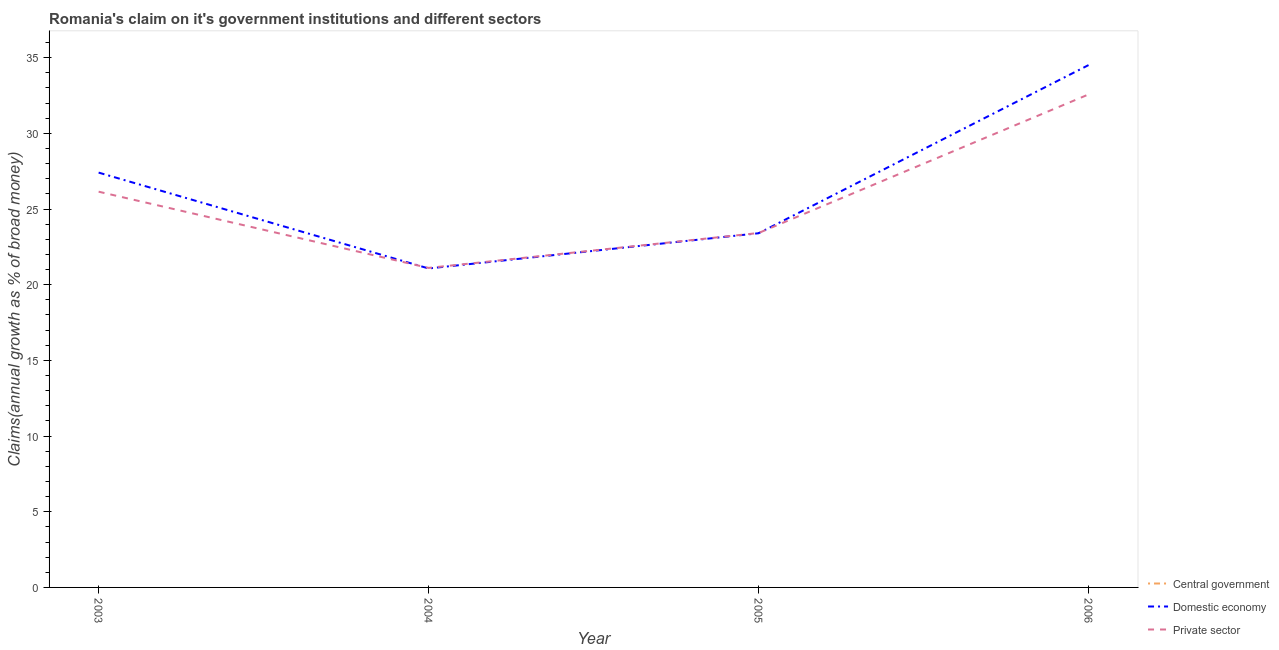Is the number of lines equal to the number of legend labels?
Offer a very short reply. No. What is the percentage of claim on the domestic economy in 2003?
Your answer should be compact. 27.41. Across all years, what is the maximum percentage of claim on the domestic economy?
Your answer should be compact. 34.51. In which year was the percentage of claim on the private sector maximum?
Your answer should be compact. 2006. What is the total percentage of claim on the domestic economy in the graph?
Offer a terse response. 106.39. What is the difference between the percentage of claim on the private sector in 2004 and that in 2005?
Provide a succinct answer. -2.31. What is the difference between the percentage of claim on the domestic economy in 2006 and the percentage of claim on the private sector in 2004?
Your answer should be compact. 13.4. In the year 2006, what is the difference between the percentage of claim on the domestic economy and percentage of claim on the private sector?
Your response must be concise. 1.94. What is the ratio of the percentage of claim on the domestic economy in 2003 to that in 2006?
Offer a terse response. 0.79. What is the difference between the highest and the second highest percentage of claim on the private sector?
Make the answer very short. 6.43. What is the difference between the highest and the lowest percentage of claim on the private sector?
Your response must be concise. 11.46. In how many years, is the percentage of claim on the private sector greater than the average percentage of claim on the private sector taken over all years?
Make the answer very short. 2. Does the percentage of claim on the central government monotonically increase over the years?
Your response must be concise. No. Is the percentage of claim on the domestic economy strictly less than the percentage of claim on the private sector over the years?
Your answer should be very brief. No. How many lines are there?
Your answer should be compact. 2. How many years are there in the graph?
Offer a very short reply. 4. What is the difference between two consecutive major ticks on the Y-axis?
Provide a succinct answer. 5. Does the graph contain grids?
Your answer should be very brief. No. Where does the legend appear in the graph?
Provide a succinct answer. Bottom right. How many legend labels are there?
Provide a succinct answer. 3. What is the title of the graph?
Keep it short and to the point. Romania's claim on it's government institutions and different sectors. Does "Social Protection and Labor" appear as one of the legend labels in the graph?
Ensure brevity in your answer.  No. What is the label or title of the X-axis?
Give a very brief answer. Year. What is the label or title of the Y-axis?
Provide a succinct answer. Claims(annual growth as % of broad money). What is the Claims(annual growth as % of broad money) of Domestic economy in 2003?
Make the answer very short. 27.41. What is the Claims(annual growth as % of broad money) in Private sector in 2003?
Your response must be concise. 26.15. What is the Claims(annual growth as % of broad money) in Central government in 2004?
Provide a succinct answer. 0. What is the Claims(annual growth as % of broad money) of Domestic economy in 2004?
Offer a terse response. 21.07. What is the Claims(annual growth as % of broad money) of Private sector in 2004?
Make the answer very short. 21.11. What is the Claims(annual growth as % of broad money) in Domestic economy in 2005?
Offer a very short reply. 23.4. What is the Claims(annual growth as % of broad money) of Private sector in 2005?
Ensure brevity in your answer.  23.42. What is the Claims(annual growth as % of broad money) of Central government in 2006?
Offer a very short reply. 0. What is the Claims(annual growth as % of broad money) in Domestic economy in 2006?
Keep it short and to the point. 34.51. What is the Claims(annual growth as % of broad money) in Private sector in 2006?
Make the answer very short. 32.57. Across all years, what is the maximum Claims(annual growth as % of broad money) of Domestic economy?
Ensure brevity in your answer.  34.51. Across all years, what is the maximum Claims(annual growth as % of broad money) of Private sector?
Your answer should be compact. 32.57. Across all years, what is the minimum Claims(annual growth as % of broad money) of Domestic economy?
Your answer should be compact. 21.07. Across all years, what is the minimum Claims(annual growth as % of broad money) in Private sector?
Make the answer very short. 21.11. What is the total Claims(annual growth as % of broad money) in Domestic economy in the graph?
Keep it short and to the point. 106.39. What is the total Claims(annual growth as % of broad money) in Private sector in the graph?
Your response must be concise. 103.25. What is the difference between the Claims(annual growth as % of broad money) of Domestic economy in 2003 and that in 2004?
Give a very brief answer. 6.33. What is the difference between the Claims(annual growth as % of broad money) in Private sector in 2003 and that in 2004?
Your response must be concise. 5.04. What is the difference between the Claims(annual growth as % of broad money) in Domestic economy in 2003 and that in 2005?
Make the answer very short. 4.01. What is the difference between the Claims(annual growth as % of broad money) in Private sector in 2003 and that in 2005?
Offer a terse response. 2.73. What is the difference between the Claims(annual growth as % of broad money) of Domestic economy in 2003 and that in 2006?
Ensure brevity in your answer.  -7.1. What is the difference between the Claims(annual growth as % of broad money) of Private sector in 2003 and that in 2006?
Give a very brief answer. -6.43. What is the difference between the Claims(annual growth as % of broad money) of Domestic economy in 2004 and that in 2005?
Your response must be concise. -2.33. What is the difference between the Claims(annual growth as % of broad money) of Private sector in 2004 and that in 2005?
Your answer should be very brief. -2.31. What is the difference between the Claims(annual growth as % of broad money) of Domestic economy in 2004 and that in 2006?
Keep it short and to the point. -13.44. What is the difference between the Claims(annual growth as % of broad money) in Private sector in 2004 and that in 2006?
Offer a terse response. -11.46. What is the difference between the Claims(annual growth as % of broad money) in Domestic economy in 2005 and that in 2006?
Offer a very short reply. -11.11. What is the difference between the Claims(annual growth as % of broad money) of Private sector in 2005 and that in 2006?
Offer a very short reply. -9.16. What is the difference between the Claims(annual growth as % of broad money) in Domestic economy in 2003 and the Claims(annual growth as % of broad money) in Private sector in 2004?
Ensure brevity in your answer.  6.3. What is the difference between the Claims(annual growth as % of broad money) in Domestic economy in 2003 and the Claims(annual growth as % of broad money) in Private sector in 2005?
Your answer should be compact. 3.99. What is the difference between the Claims(annual growth as % of broad money) in Domestic economy in 2003 and the Claims(annual growth as % of broad money) in Private sector in 2006?
Provide a short and direct response. -5.16. What is the difference between the Claims(annual growth as % of broad money) in Domestic economy in 2004 and the Claims(annual growth as % of broad money) in Private sector in 2005?
Give a very brief answer. -2.34. What is the difference between the Claims(annual growth as % of broad money) of Domestic economy in 2004 and the Claims(annual growth as % of broad money) of Private sector in 2006?
Your answer should be very brief. -11.5. What is the difference between the Claims(annual growth as % of broad money) in Domestic economy in 2005 and the Claims(annual growth as % of broad money) in Private sector in 2006?
Your answer should be compact. -9.17. What is the average Claims(annual growth as % of broad money) in Central government per year?
Keep it short and to the point. 0. What is the average Claims(annual growth as % of broad money) of Domestic economy per year?
Your response must be concise. 26.6. What is the average Claims(annual growth as % of broad money) in Private sector per year?
Keep it short and to the point. 25.81. In the year 2003, what is the difference between the Claims(annual growth as % of broad money) of Domestic economy and Claims(annual growth as % of broad money) of Private sector?
Your answer should be very brief. 1.26. In the year 2004, what is the difference between the Claims(annual growth as % of broad money) of Domestic economy and Claims(annual growth as % of broad money) of Private sector?
Give a very brief answer. -0.04. In the year 2005, what is the difference between the Claims(annual growth as % of broad money) of Domestic economy and Claims(annual growth as % of broad money) of Private sector?
Make the answer very short. -0.02. In the year 2006, what is the difference between the Claims(annual growth as % of broad money) in Domestic economy and Claims(annual growth as % of broad money) in Private sector?
Give a very brief answer. 1.94. What is the ratio of the Claims(annual growth as % of broad money) of Domestic economy in 2003 to that in 2004?
Your response must be concise. 1.3. What is the ratio of the Claims(annual growth as % of broad money) of Private sector in 2003 to that in 2004?
Your response must be concise. 1.24. What is the ratio of the Claims(annual growth as % of broad money) in Domestic economy in 2003 to that in 2005?
Offer a very short reply. 1.17. What is the ratio of the Claims(annual growth as % of broad money) of Private sector in 2003 to that in 2005?
Ensure brevity in your answer.  1.12. What is the ratio of the Claims(annual growth as % of broad money) in Domestic economy in 2003 to that in 2006?
Ensure brevity in your answer.  0.79. What is the ratio of the Claims(annual growth as % of broad money) of Private sector in 2003 to that in 2006?
Offer a terse response. 0.8. What is the ratio of the Claims(annual growth as % of broad money) in Domestic economy in 2004 to that in 2005?
Your answer should be very brief. 0.9. What is the ratio of the Claims(annual growth as % of broad money) of Private sector in 2004 to that in 2005?
Ensure brevity in your answer.  0.9. What is the ratio of the Claims(annual growth as % of broad money) in Domestic economy in 2004 to that in 2006?
Your answer should be compact. 0.61. What is the ratio of the Claims(annual growth as % of broad money) of Private sector in 2004 to that in 2006?
Make the answer very short. 0.65. What is the ratio of the Claims(annual growth as % of broad money) in Domestic economy in 2005 to that in 2006?
Your answer should be very brief. 0.68. What is the ratio of the Claims(annual growth as % of broad money) of Private sector in 2005 to that in 2006?
Your answer should be compact. 0.72. What is the difference between the highest and the second highest Claims(annual growth as % of broad money) of Domestic economy?
Ensure brevity in your answer.  7.1. What is the difference between the highest and the second highest Claims(annual growth as % of broad money) of Private sector?
Give a very brief answer. 6.43. What is the difference between the highest and the lowest Claims(annual growth as % of broad money) in Domestic economy?
Provide a succinct answer. 13.44. What is the difference between the highest and the lowest Claims(annual growth as % of broad money) in Private sector?
Make the answer very short. 11.46. 